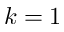Convert formula to latex. <formula><loc_0><loc_0><loc_500><loc_500>k = 1</formula> 